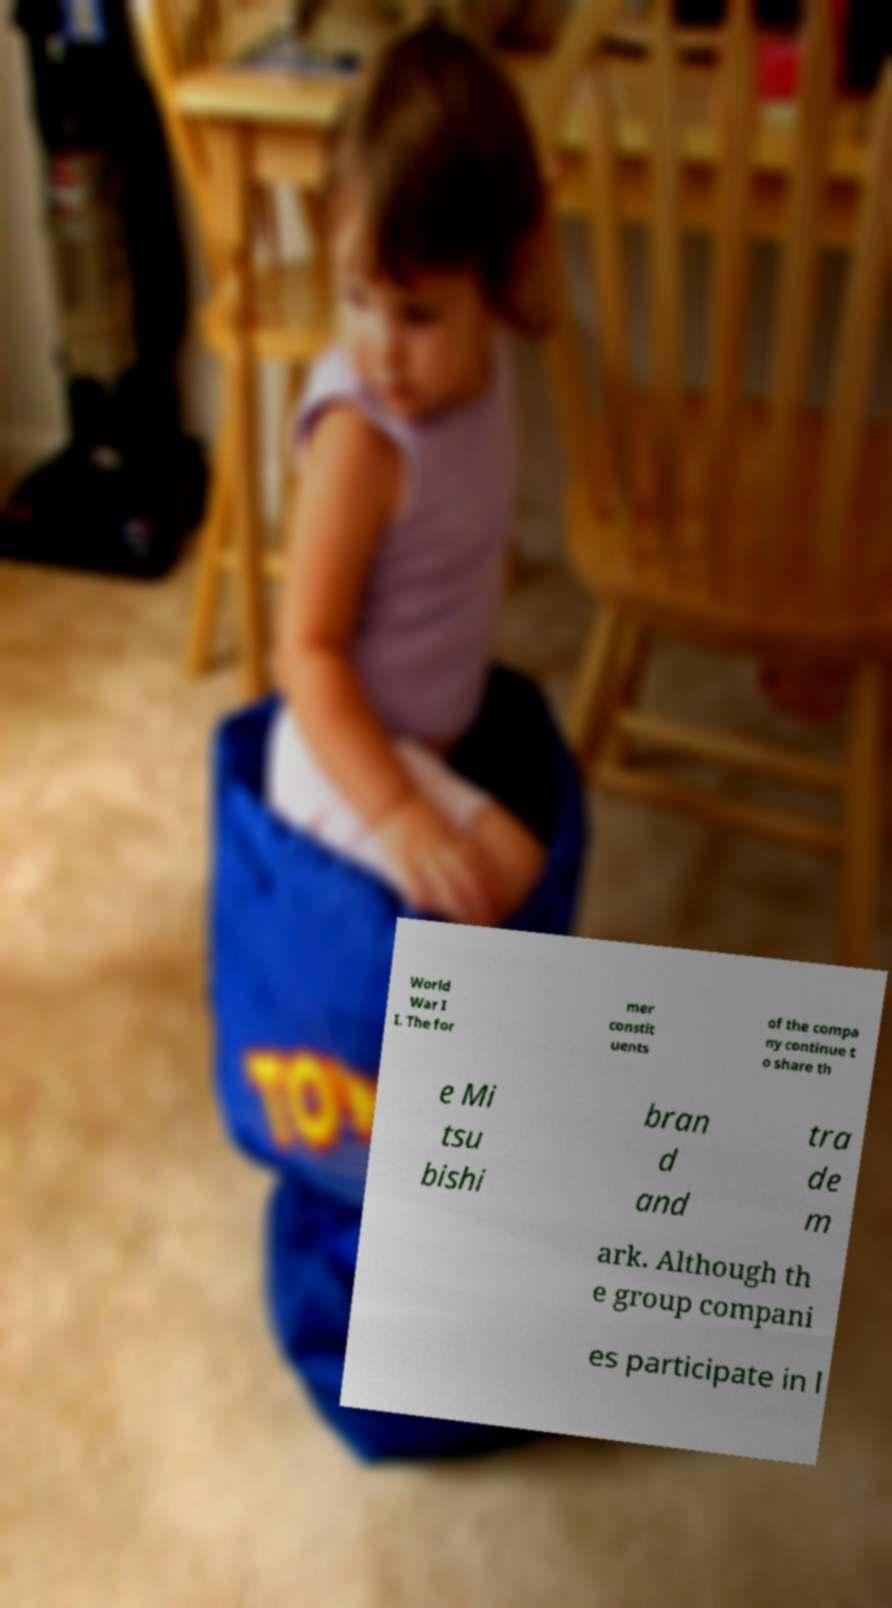Can you accurately transcribe the text from the provided image for me? World War I I. The for mer constit uents of the compa ny continue t o share th e Mi tsu bishi bran d and tra de m ark. Although th e group compani es participate in l 